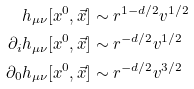Convert formula to latex. <formula><loc_0><loc_0><loc_500><loc_500>h _ { \mu \nu } [ x ^ { 0 } , \vec { x } ] & \sim r ^ { 1 - d / 2 } v ^ { 1 / 2 } \\ \partial _ { i } h _ { \mu \nu } [ x ^ { 0 } , \vec { x } ] & \sim r ^ { - d / 2 } v ^ { 1 / 2 } \\ \partial _ { 0 } h _ { \mu \nu } [ x ^ { 0 } , \vec { x } ] & \sim r ^ { - d / 2 } v ^ { 3 / 2 }</formula> 